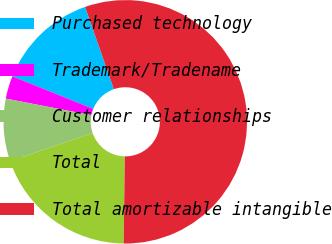<chart> <loc_0><loc_0><loc_500><loc_500><pie_chart><fcel>Purchased technology<fcel>Trademark/Tradename<fcel>Customer relationships<fcel>Total<fcel>Total amortizable intangible<nl><fcel>13.55%<fcel>3.04%<fcel>8.3%<fcel>19.54%<fcel>55.58%<nl></chart> 